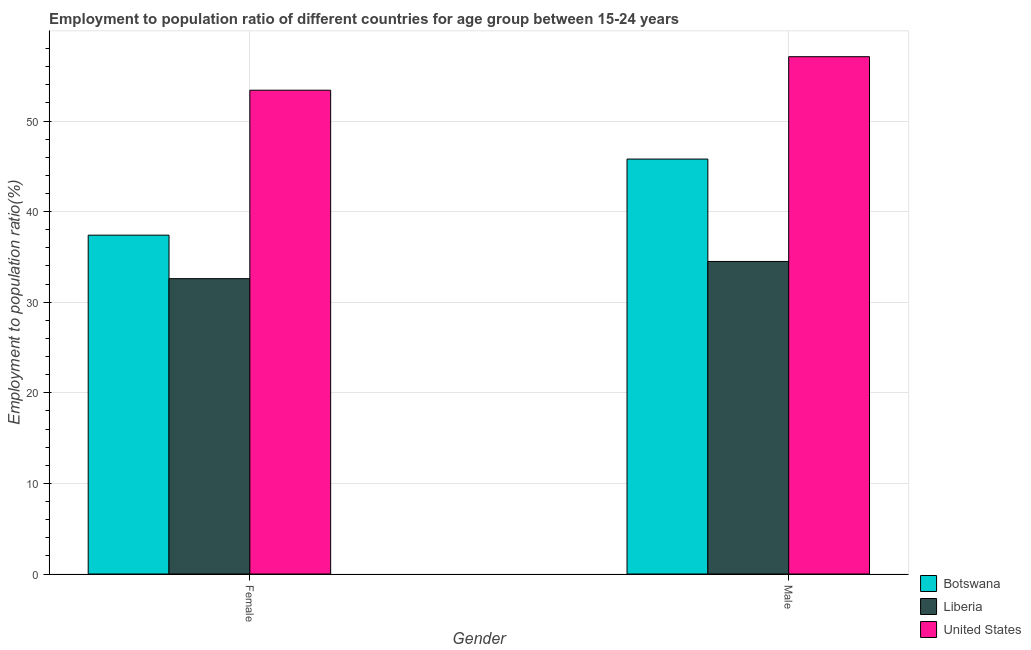How many different coloured bars are there?
Provide a short and direct response. 3. Are the number of bars per tick equal to the number of legend labels?
Make the answer very short. Yes. Are the number of bars on each tick of the X-axis equal?
Your answer should be very brief. Yes. How many bars are there on the 1st tick from the right?
Offer a terse response. 3. What is the employment to population ratio(female) in Liberia?
Offer a very short reply. 32.6. Across all countries, what is the maximum employment to population ratio(male)?
Your response must be concise. 57.1. Across all countries, what is the minimum employment to population ratio(female)?
Offer a terse response. 32.6. In which country was the employment to population ratio(female) minimum?
Provide a short and direct response. Liberia. What is the total employment to population ratio(female) in the graph?
Keep it short and to the point. 123.4. What is the difference between the employment to population ratio(female) in Botswana and that in United States?
Keep it short and to the point. -16. What is the difference between the employment to population ratio(female) in Liberia and the employment to population ratio(male) in United States?
Keep it short and to the point. -24.5. What is the average employment to population ratio(female) per country?
Keep it short and to the point. 41.13. What is the difference between the employment to population ratio(male) and employment to population ratio(female) in Liberia?
Offer a terse response. 1.9. What is the ratio of the employment to population ratio(female) in United States to that in Liberia?
Keep it short and to the point. 1.64. In how many countries, is the employment to population ratio(male) greater than the average employment to population ratio(male) taken over all countries?
Make the answer very short. 1. What does the 3rd bar from the left in Female represents?
Keep it short and to the point. United States. How many bars are there?
Make the answer very short. 6. Are all the bars in the graph horizontal?
Your answer should be very brief. No. How many countries are there in the graph?
Make the answer very short. 3. What is the difference between two consecutive major ticks on the Y-axis?
Give a very brief answer. 10. Does the graph contain any zero values?
Provide a succinct answer. No. Does the graph contain grids?
Your answer should be compact. Yes. Where does the legend appear in the graph?
Provide a short and direct response. Bottom right. What is the title of the graph?
Provide a succinct answer. Employment to population ratio of different countries for age group between 15-24 years. What is the label or title of the X-axis?
Your response must be concise. Gender. What is the Employment to population ratio(%) of Botswana in Female?
Give a very brief answer. 37.4. What is the Employment to population ratio(%) of Liberia in Female?
Offer a terse response. 32.6. What is the Employment to population ratio(%) of United States in Female?
Your answer should be compact. 53.4. What is the Employment to population ratio(%) in Botswana in Male?
Offer a very short reply. 45.8. What is the Employment to population ratio(%) of Liberia in Male?
Give a very brief answer. 34.5. What is the Employment to population ratio(%) in United States in Male?
Offer a very short reply. 57.1. Across all Gender, what is the maximum Employment to population ratio(%) in Botswana?
Your response must be concise. 45.8. Across all Gender, what is the maximum Employment to population ratio(%) in Liberia?
Offer a terse response. 34.5. Across all Gender, what is the maximum Employment to population ratio(%) of United States?
Provide a succinct answer. 57.1. Across all Gender, what is the minimum Employment to population ratio(%) in Botswana?
Ensure brevity in your answer.  37.4. Across all Gender, what is the minimum Employment to population ratio(%) in Liberia?
Keep it short and to the point. 32.6. Across all Gender, what is the minimum Employment to population ratio(%) in United States?
Offer a terse response. 53.4. What is the total Employment to population ratio(%) in Botswana in the graph?
Your answer should be compact. 83.2. What is the total Employment to population ratio(%) in Liberia in the graph?
Your answer should be very brief. 67.1. What is the total Employment to population ratio(%) of United States in the graph?
Your answer should be compact. 110.5. What is the difference between the Employment to population ratio(%) of Botswana in Female and that in Male?
Offer a terse response. -8.4. What is the difference between the Employment to population ratio(%) of Liberia in Female and that in Male?
Keep it short and to the point. -1.9. What is the difference between the Employment to population ratio(%) in United States in Female and that in Male?
Your answer should be very brief. -3.7. What is the difference between the Employment to population ratio(%) of Botswana in Female and the Employment to population ratio(%) of United States in Male?
Your answer should be very brief. -19.7. What is the difference between the Employment to population ratio(%) of Liberia in Female and the Employment to population ratio(%) of United States in Male?
Ensure brevity in your answer.  -24.5. What is the average Employment to population ratio(%) in Botswana per Gender?
Give a very brief answer. 41.6. What is the average Employment to population ratio(%) of Liberia per Gender?
Offer a terse response. 33.55. What is the average Employment to population ratio(%) in United States per Gender?
Make the answer very short. 55.25. What is the difference between the Employment to population ratio(%) of Botswana and Employment to population ratio(%) of Liberia in Female?
Make the answer very short. 4.8. What is the difference between the Employment to population ratio(%) of Botswana and Employment to population ratio(%) of United States in Female?
Offer a terse response. -16. What is the difference between the Employment to population ratio(%) in Liberia and Employment to population ratio(%) in United States in Female?
Offer a very short reply. -20.8. What is the difference between the Employment to population ratio(%) in Liberia and Employment to population ratio(%) in United States in Male?
Keep it short and to the point. -22.6. What is the ratio of the Employment to population ratio(%) in Botswana in Female to that in Male?
Keep it short and to the point. 0.82. What is the ratio of the Employment to population ratio(%) in Liberia in Female to that in Male?
Your response must be concise. 0.94. What is the ratio of the Employment to population ratio(%) in United States in Female to that in Male?
Your response must be concise. 0.94. What is the difference between the highest and the second highest Employment to population ratio(%) in Botswana?
Keep it short and to the point. 8.4. What is the difference between the highest and the second highest Employment to population ratio(%) in Liberia?
Your answer should be very brief. 1.9. What is the difference between the highest and the lowest Employment to population ratio(%) of Botswana?
Keep it short and to the point. 8.4. What is the difference between the highest and the lowest Employment to population ratio(%) in United States?
Your answer should be very brief. 3.7. 